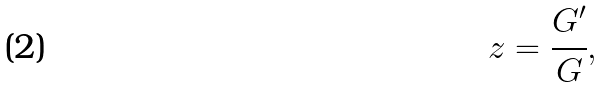Convert formula to latex. <formula><loc_0><loc_0><loc_500><loc_500>z = \cfrac { G ^ { \prime } } { G } ,</formula> 